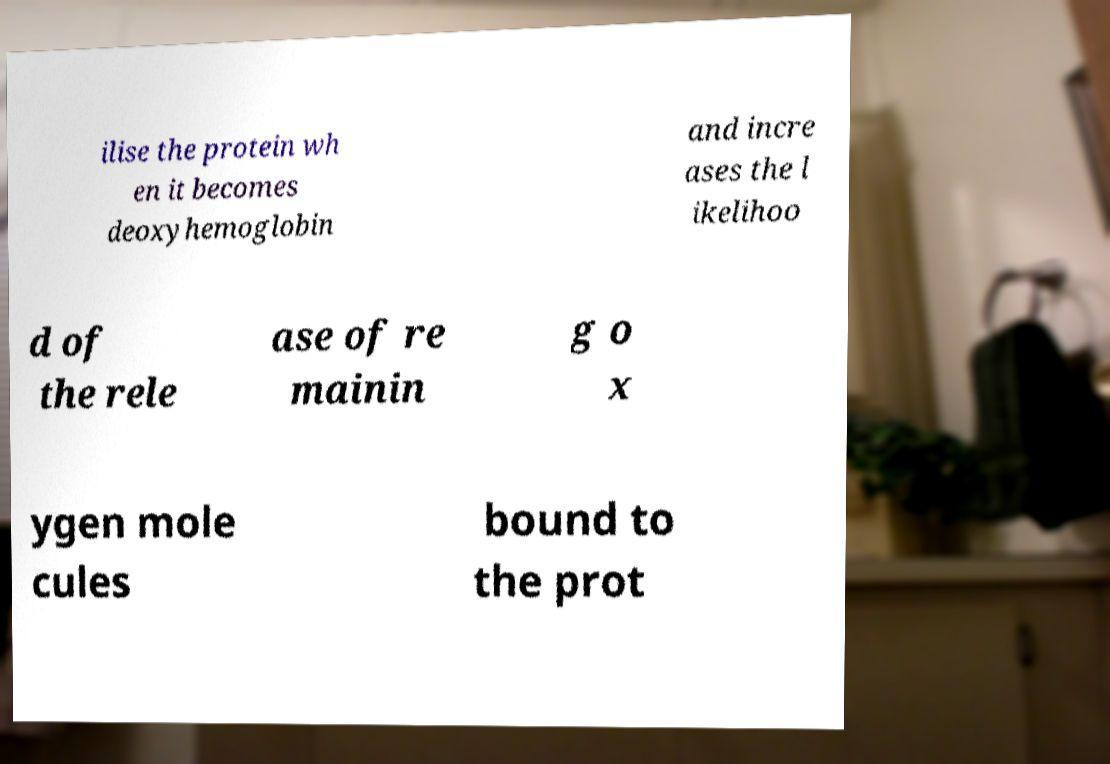Please read and relay the text visible in this image. What does it say? ilise the protein wh en it becomes deoxyhemoglobin and incre ases the l ikelihoo d of the rele ase of re mainin g o x ygen mole cules bound to the prot 